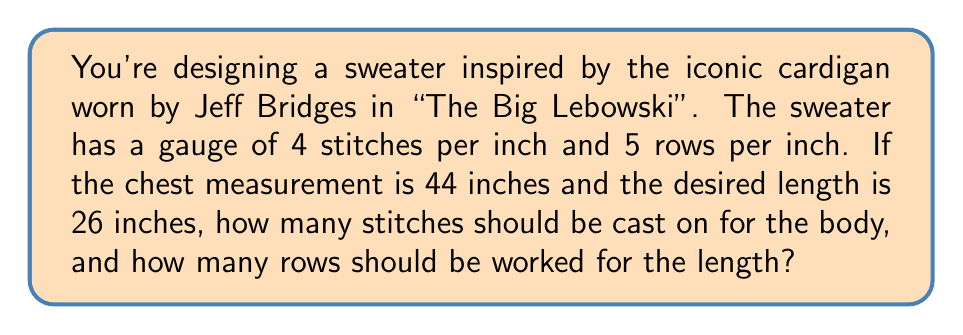Provide a solution to this math problem. Let's break this down step-by-step:

1. Calculate stitches for chest:
   - Gauge: 4 stitches per inch
   - Chest measurement: 44 inches
   - Stitches needed = $44 \times 4 = 176$ stitches

2. Calculate rows for length:
   - Gauge: 5 rows per inch
   - Desired length: 26 inches
   - Rows needed = $26 \times 5 = 130$ rows

3. Final calculations:
   - Stitches to cast on: 176
   - Rows to work: 130

Note: In actual knitting, you might want to add some ease (extra width) to the chest measurement and consider factors like ribbing at the bottom. However, for this algebraic calculation, we'll stick to the given measurements.
Answer: 176 stitches, 130 rows 